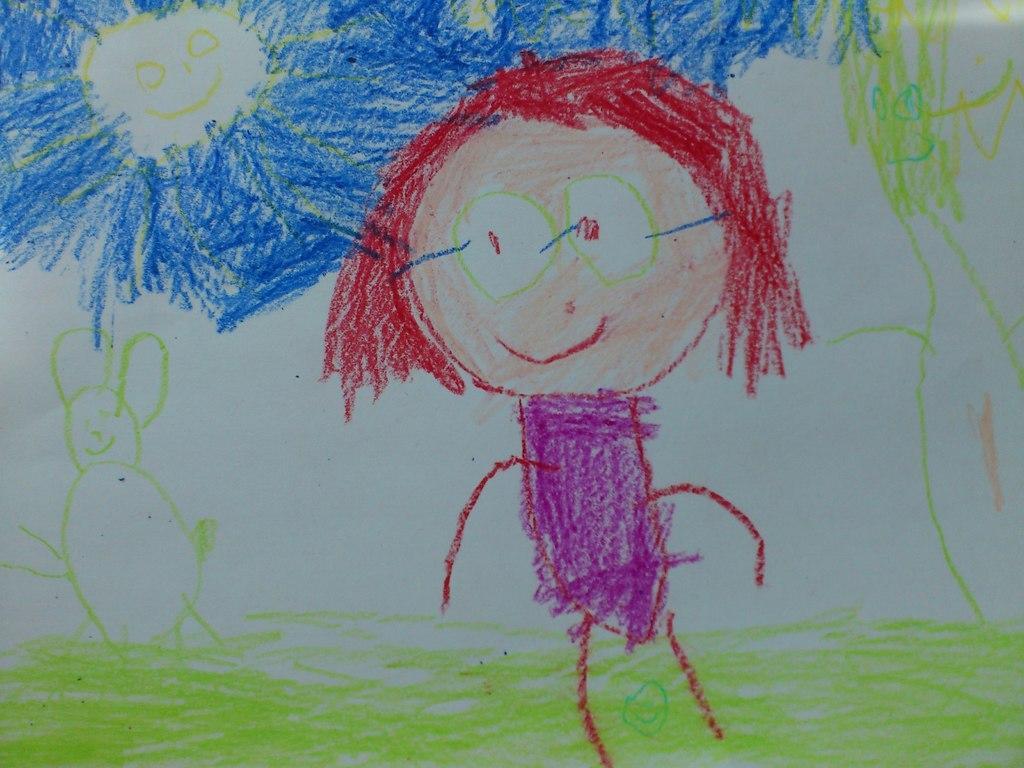Please provide a concise description of this image. In this image I can see the drawing on the white color surface and I can see the drawing of few objects in multi color. 